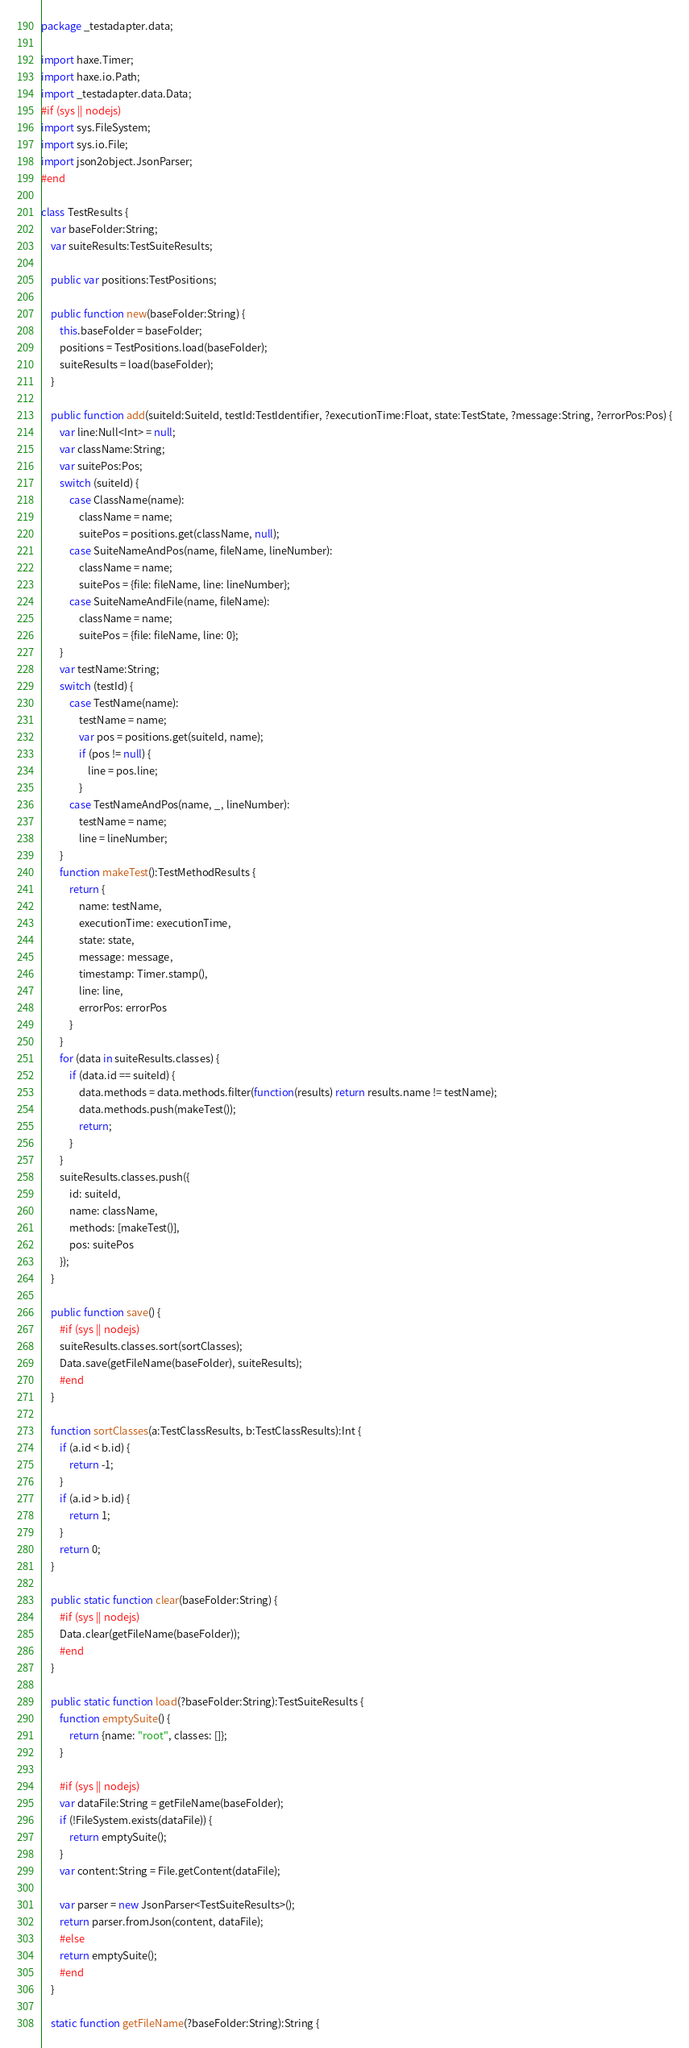<code> <loc_0><loc_0><loc_500><loc_500><_Haxe_>package _testadapter.data;

import haxe.Timer;
import haxe.io.Path;
import _testadapter.data.Data;
#if (sys || nodejs)
import sys.FileSystem;
import sys.io.File;
import json2object.JsonParser;
#end

class TestResults {
	var baseFolder:String;
	var suiteResults:TestSuiteResults;

	public var positions:TestPositions;

	public function new(baseFolder:String) {
		this.baseFolder = baseFolder;
		positions = TestPositions.load(baseFolder);
		suiteResults = load(baseFolder);
	}

	public function add(suiteId:SuiteId, testId:TestIdentifier, ?executionTime:Float, state:TestState, ?message:String, ?errorPos:Pos) {
		var line:Null<Int> = null;
		var className:String;
		var suitePos:Pos;
		switch (suiteId) {
			case ClassName(name):
				className = name;
				suitePos = positions.get(className, null);
			case SuiteNameAndPos(name, fileName, lineNumber):
				className = name;
				suitePos = {file: fileName, line: lineNumber};
			case SuiteNameAndFile(name, fileName):
				className = name;
				suitePos = {file: fileName, line: 0};
		}
		var testName:String;
		switch (testId) {
			case TestName(name):
				testName = name;
				var pos = positions.get(suiteId, name);
				if (pos != null) {
					line = pos.line;
				}
			case TestNameAndPos(name, _, lineNumber):
				testName = name;
				line = lineNumber;
		}
		function makeTest():TestMethodResults {
			return {
				name: testName,
				executionTime: executionTime,
				state: state,
				message: message,
				timestamp: Timer.stamp(),
				line: line,
				errorPos: errorPos
			}
		}
		for (data in suiteResults.classes) {
			if (data.id == suiteId) {
				data.methods = data.methods.filter(function(results) return results.name != testName);
				data.methods.push(makeTest());
				return;
			}
		}
		suiteResults.classes.push({
			id: suiteId,
			name: className,
			methods: [makeTest()],
			pos: suitePos
		});
	}

	public function save() {
		#if (sys || nodejs)
		suiteResults.classes.sort(sortClasses);
		Data.save(getFileName(baseFolder), suiteResults);
		#end
	}

	function sortClasses(a:TestClassResults, b:TestClassResults):Int {
		if (a.id < b.id) {
			return -1;
		}
		if (a.id > b.id) {
			return 1;
		}
		return 0;
	}

	public static function clear(baseFolder:String) {
		#if (sys || nodejs)
		Data.clear(getFileName(baseFolder));
		#end
	}

	public static function load(?baseFolder:String):TestSuiteResults {
		function emptySuite() {
			return {name: "root", classes: []};
		}

		#if (sys || nodejs)
		var dataFile:String = getFileName(baseFolder);
		if (!FileSystem.exists(dataFile)) {
			return emptySuite();
		}
		var content:String = File.getContent(dataFile);

		var parser = new JsonParser<TestSuiteResults>();
		return parser.fromJson(content, dataFile);
		#else
		return emptySuite();
		#end
	}

	static function getFileName(?baseFolder:String):String {</code> 